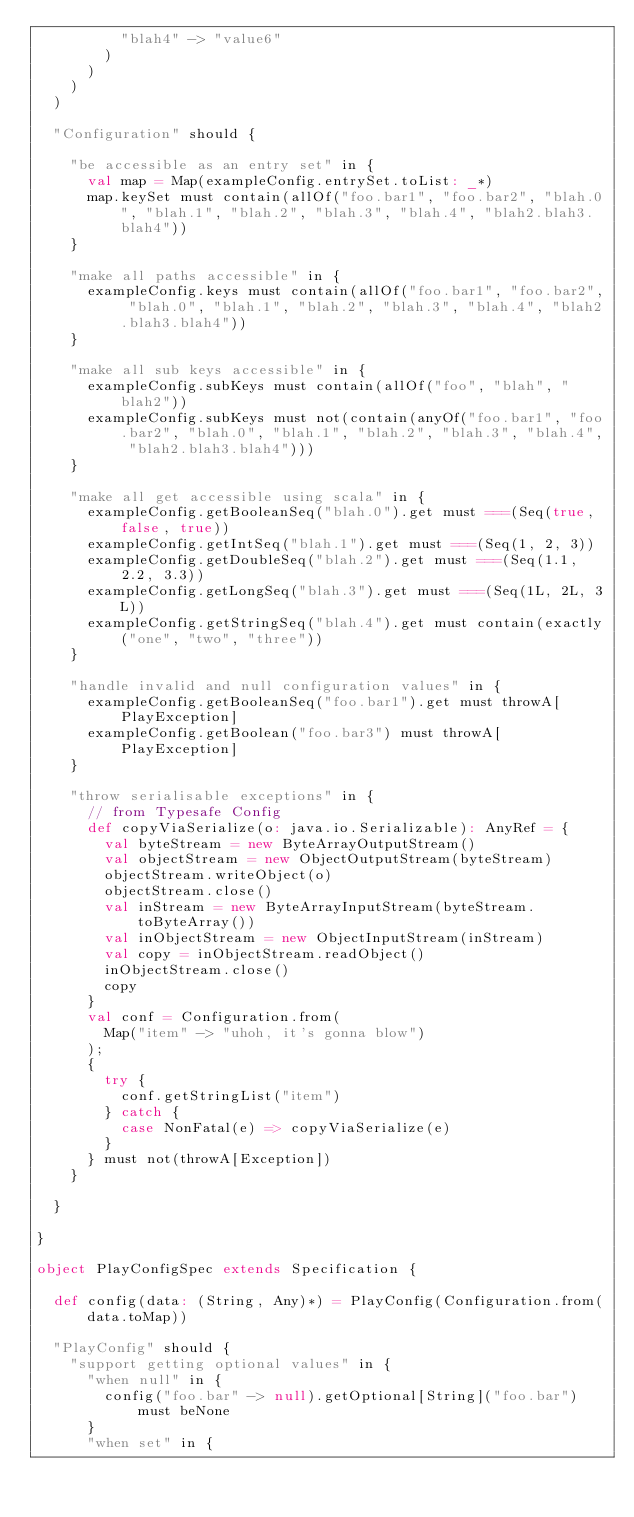<code> <loc_0><loc_0><loc_500><loc_500><_Scala_>          "blah4" -> "value6"
        )
      )
    )
  )

  "Configuration" should {

    "be accessible as an entry set" in {
      val map = Map(exampleConfig.entrySet.toList: _*)
      map.keySet must contain(allOf("foo.bar1", "foo.bar2", "blah.0", "blah.1", "blah.2", "blah.3", "blah.4", "blah2.blah3.blah4"))
    }

    "make all paths accessible" in {
      exampleConfig.keys must contain(allOf("foo.bar1", "foo.bar2", "blah.0", "blah.1", "blah.2", "blah.3", "blah.4", "blah2.blah3.blah4"))
    }

    "make all sub keys accessible" in {
      exampleConfig.subKeys must contain(allOf("foo", "blah", "blah2"))
      exampleConfig.subKeys must not(contain(anyOf("foo.bar1", "foo.bar2", "blah.0", "blah.1", "blah.2", "blah.3", "blah.4", "blah2.blah3.blah4")))
    }

    "make all get accessible using scala" in {
      exampleConfig.getBooleanSeq("blah.0").get must ===(Seq(true, false, true))
      exampleConfig.getIntSeq("blah.1").get must ===(Seq(1, 2, 3))
      exampleConfig.getDoubleSeq("blah.2").get must ===(Seq(1.1, 2.2, 3.3))
      exampleConfig.getLongSeq("blah.3").get must ===(Seq(1L, 2L, 3L))
      exampleConfig.getStringSeq("blah.4").get must contain(exactly("one", "two", "three"))
    }

    "handle invalid and null configuration values" in {
      exampleConfig.getBooleanSeq("foo.bar1").get must throwA[PlayException]
      exampleConfig.getBoolean("foo.bar3") must throwA[PlayException]
    }

    "throw serialisable exceptions" in {
      // from Typesafe Config
      def copyViaSerialize(o: java.io.Serializable): AnyRef = {
        val byteStream = new ByteArrayOutputStream()
        val objectStream = new ObjectOutputStream(byteStream)
        objectStream.writeObject(o)
        objectStream.close()
        val inStream = new ByteArrayInputStream(byteStream.toByteArray())
        val inObjectStream = new ObjectInputStream(inStream)
        val copy = inObjectStream.readObject()
        inObjectStream.close()
        copy
      }
      val conf = Configuration.from(
        Map("item" -> "uhoh, it's gonna blow")
      );
      {
        try {
          conf.getStringList("item")
        } catch {
          case NonFatal(e) => copyViaSerialize(e)
        }
      } must not(throwA[Exception])
    }

  }

}

object PlayConfigSpec extends Specification {

  def config(data: (String, Any)*) = PlayConfig(Configuration.from(data.toMap))

  "PlayConfig" should {
    "support getting optional values" in {
      "when null" in {
        config("foo.bar" -> null).getOptional[String]("foo.bar") must beNone
      }
      "when set" in {</code> 